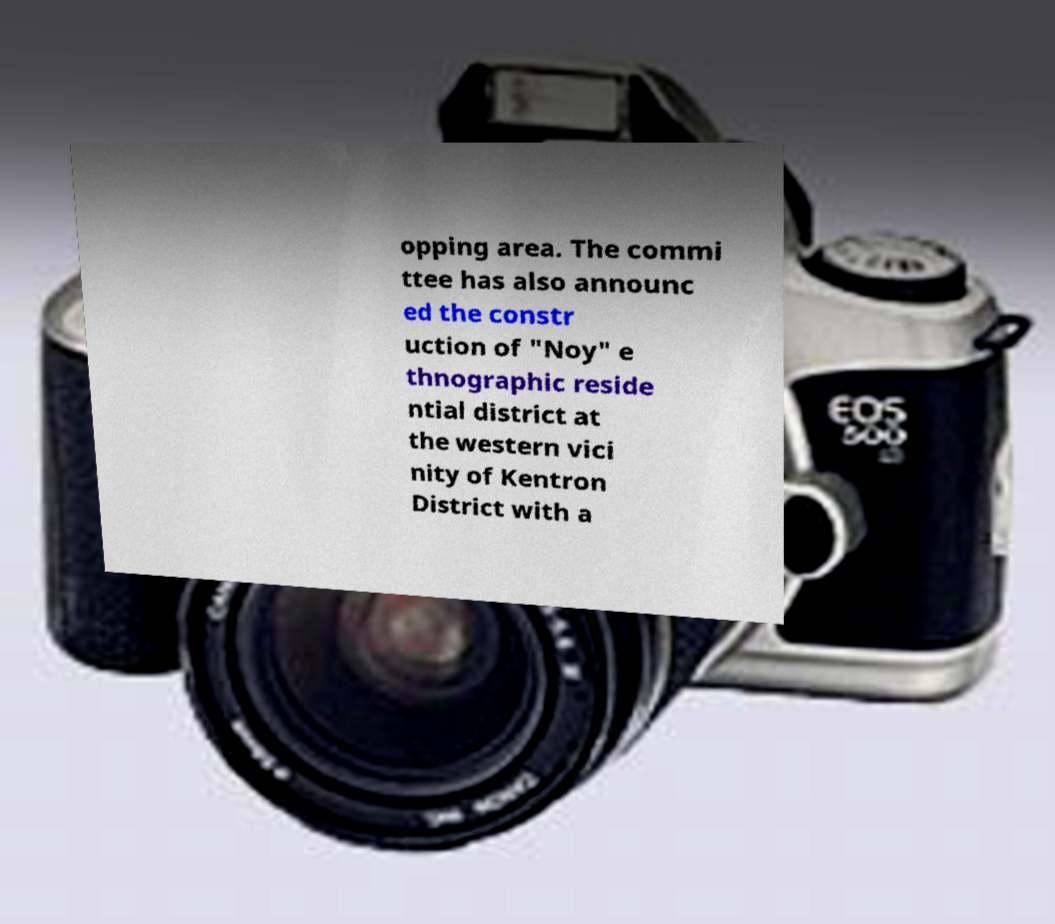Could you extract and type out the text from this image? opping area. The commi ttee has also announc ed the constr uction of "Noy" e thnographic reside ntial district at the western vici nity of Kentron District with a 